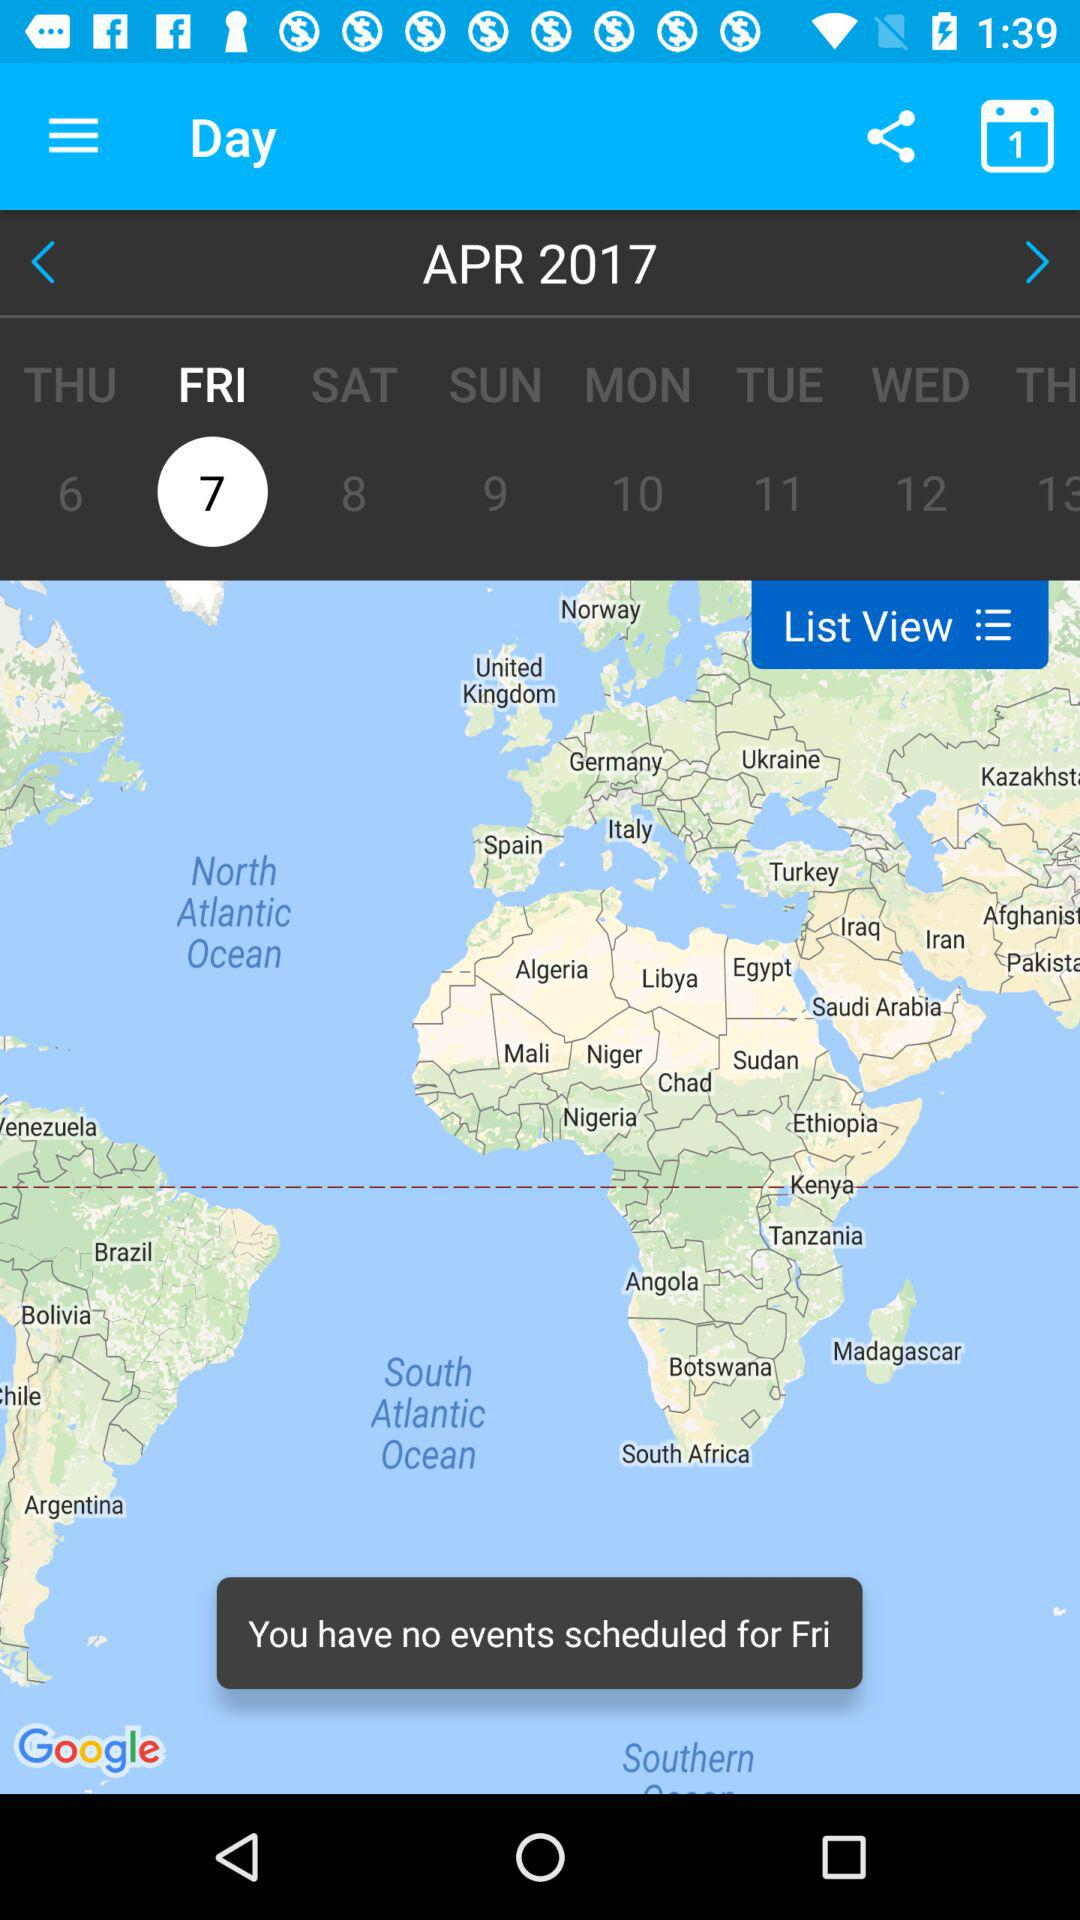What is the year? The year is 2017. 